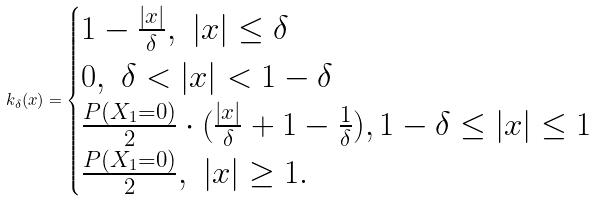<formula> <loc_0><loc_0><loc_500><loc_500>k _ { \delta } ( x ) = \begin{cases} 1 - \frac { | x | } { \delta } , \ | x | \leq \delta \\ 0 , \ \delta < | x | < 1 - \delta \\ \frac { P ( X _ { 1 } = 0 ) } { 2 } \cdot ( \frac { | x | } { \delta } + 1 - \frac { 1 } { \delta } ) , 1 - \delta \leq | x | \leq 1 \\ \frac { P ( X _ { 1 } = 0 ) } { 2 } , \ | x | \geq 1 . \end{cases}</formula> 